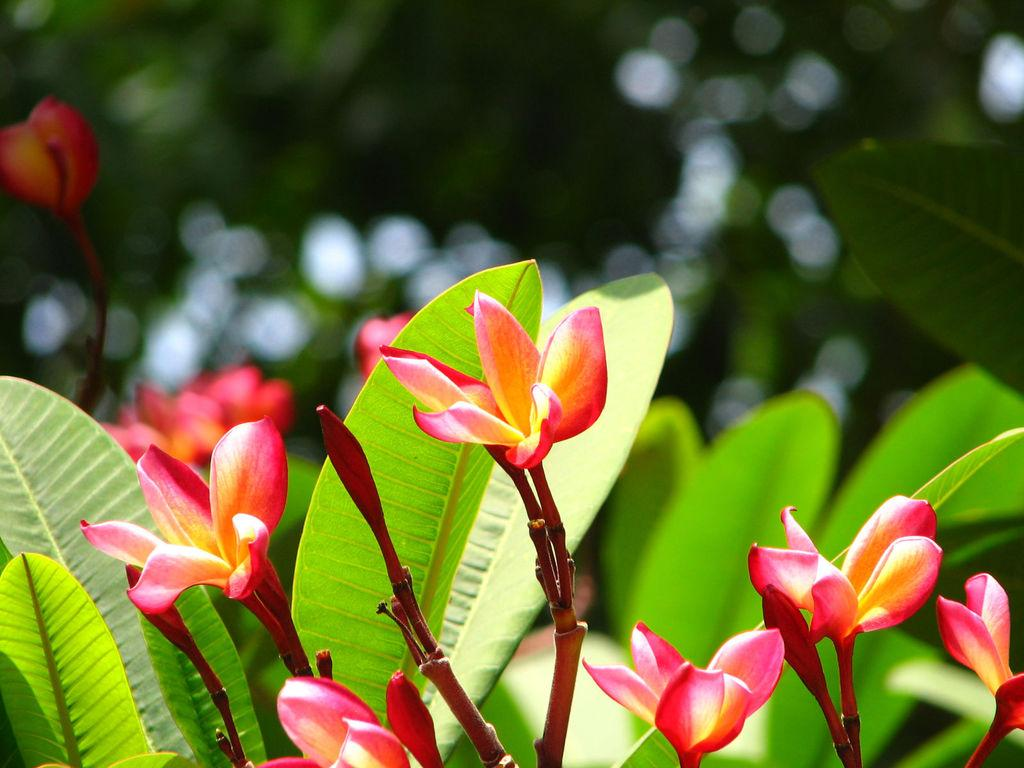What type of plants are visible in the image? There are plants with flowers in the image. Can you describe the background of the image? The background of the image is blurry. What advice does the pancake give to the flowers in the image? There is no pancake present in the image, so it cannot give any advice to the flowers. 